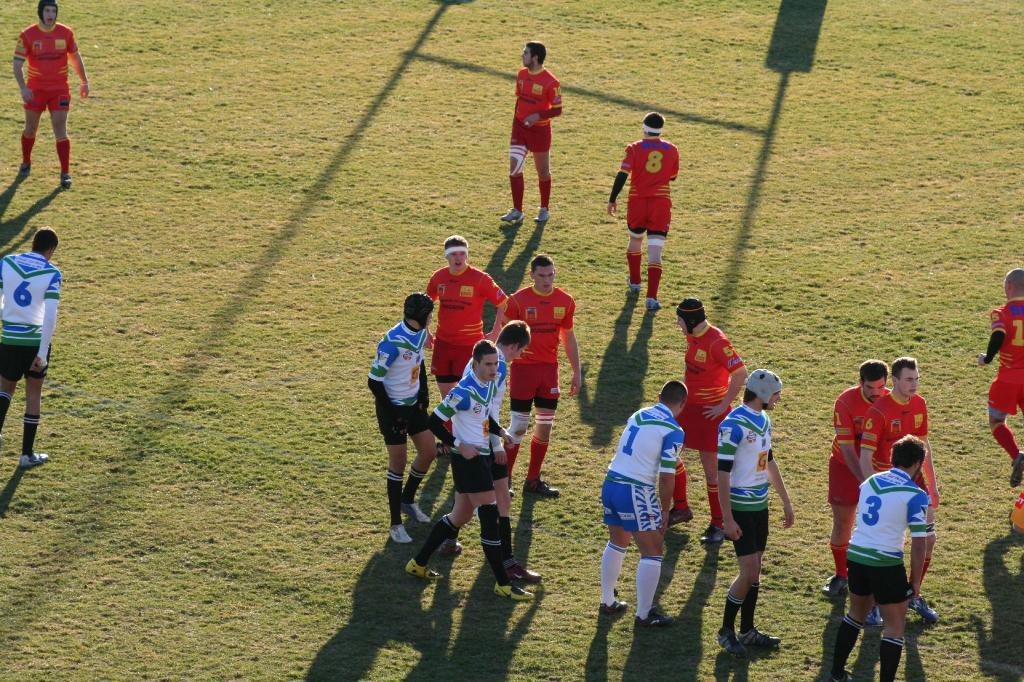Provide a one-sentence caption for the provided image. white and blue vs red teams on a grass field with number 1 on white/blue team leaned foward a bit. 